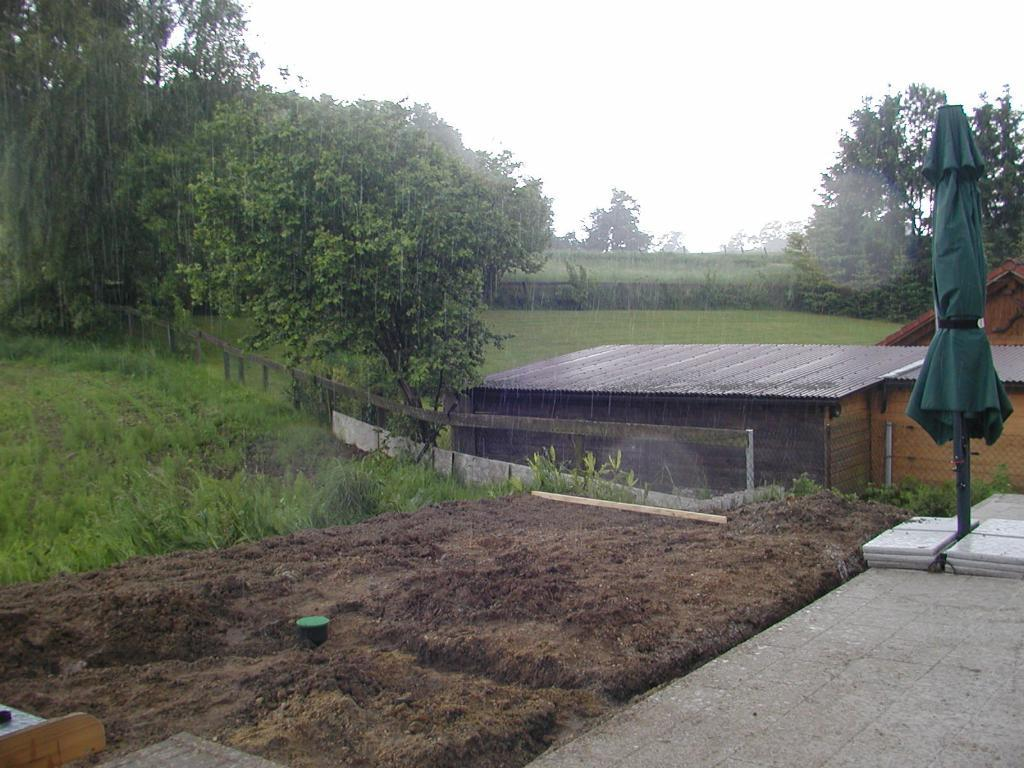What type of structures can be seen in the image? There are sheds in the image. What type of vegetation is present in the image? There are trees in the image. What type of ground cover is visible in the image? There is grass in the image. What type of barrier is present in the image? There is fencing in the image. What type of shade is provided by the trees in the image? There is no mention of shade in the provided facts, and the image does not show any indication of shade being provided by the trees. 